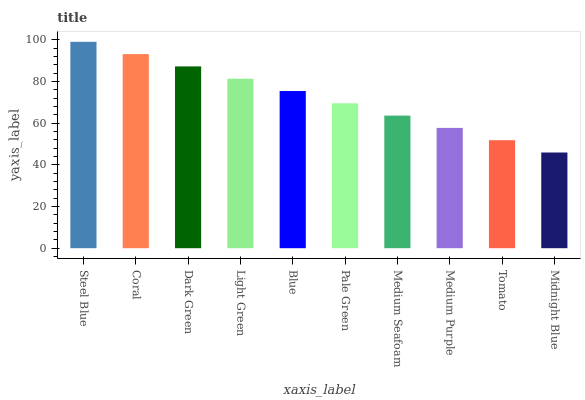Is Midnight Blue the minimum?
Answer yes or no. Yes. Is Steel Blue the maximum?
Answer yes or no. Yes. Is Coral the minimum?
Answer yes or no. No. Is Coral the maximum?
Answer yes or no. No. Is Steel Blue greater than Coral?
Answer yes or no. Yes. Is Coral less than Steel Blue?
Answer yes or no. Yes. Is Coral greater than Steel Blue?
Answer yes or no. No. Is Steel Blue less than Coral?
Answer yes or no. No. Is Blue the high median?
Answer yes or no. Yes. Is Pale Green the low median?
Answer yes or no. Yes. Is Coral the high median?
Answer yes or no. No. Is Blue the low median?
Answer yes or no. No. 